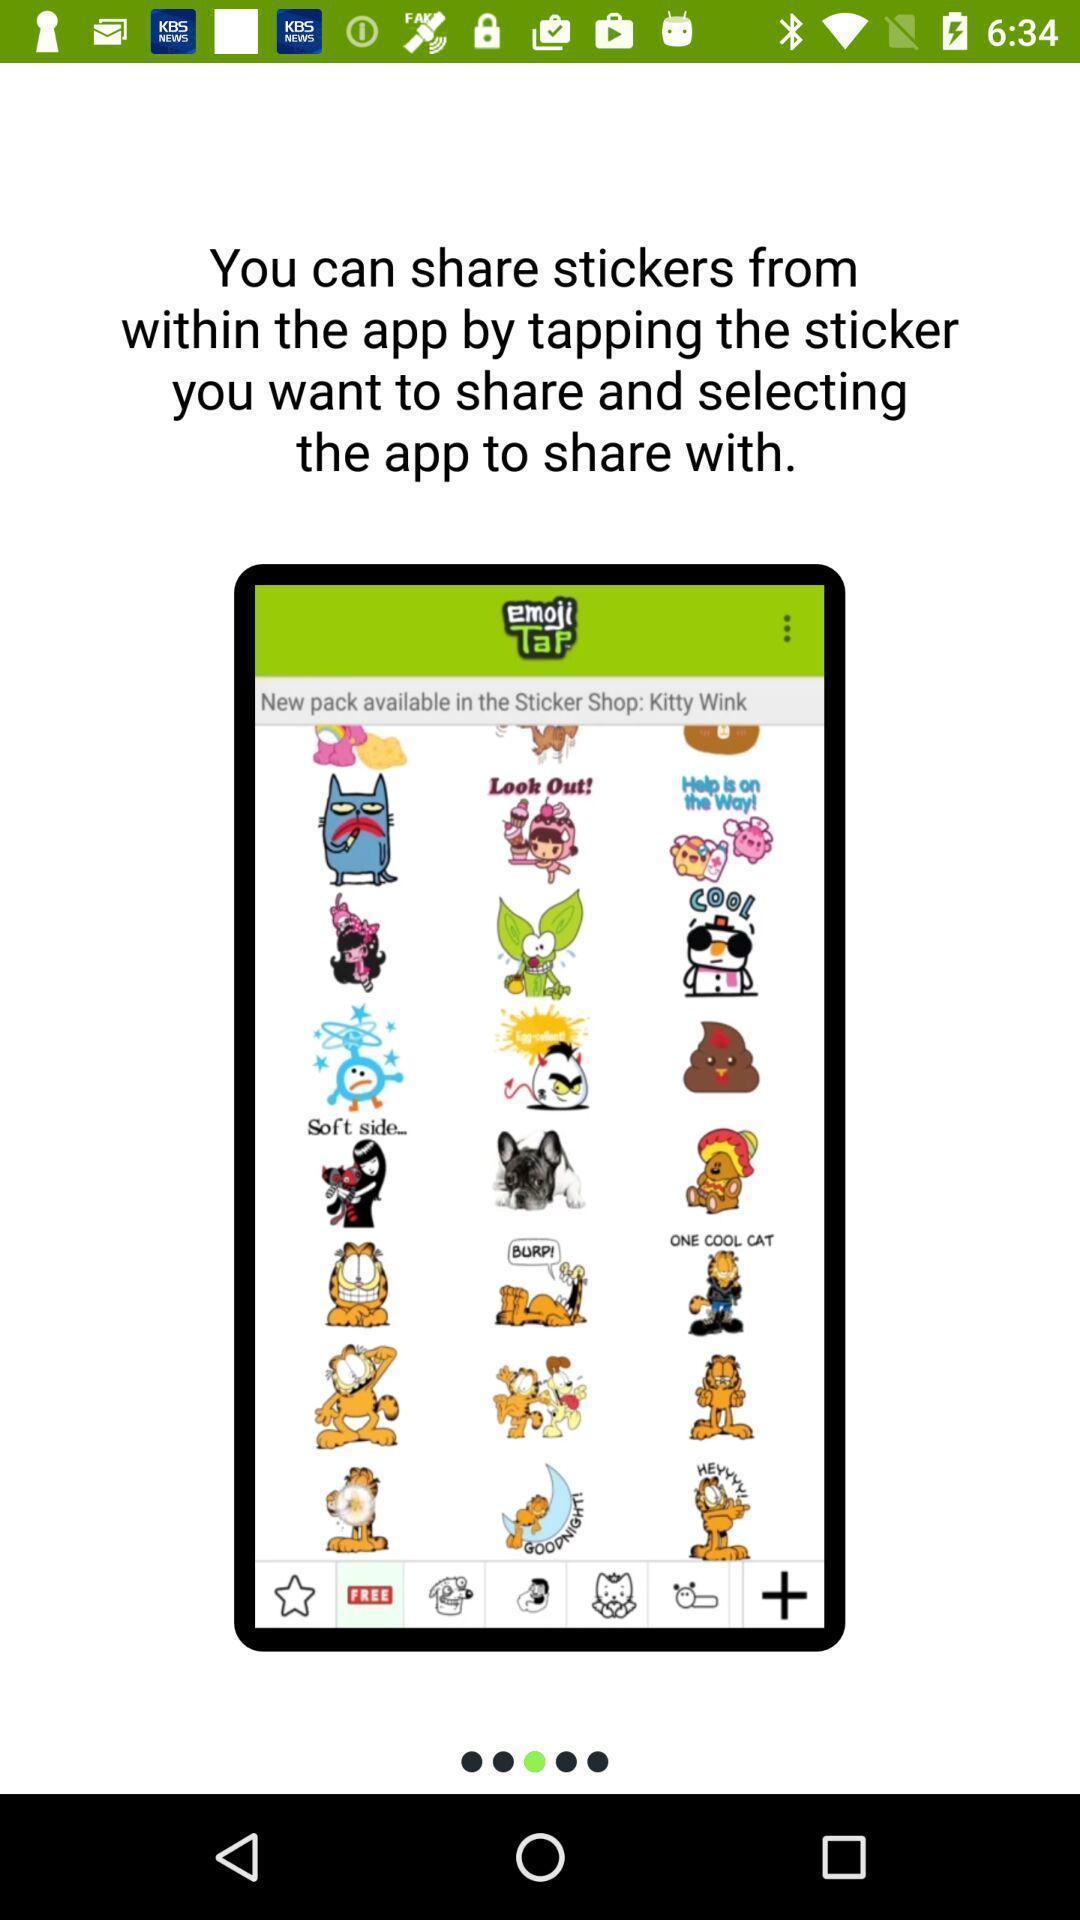Tell me about the visual elements in this screen capture. Page displaying the share stickers. 